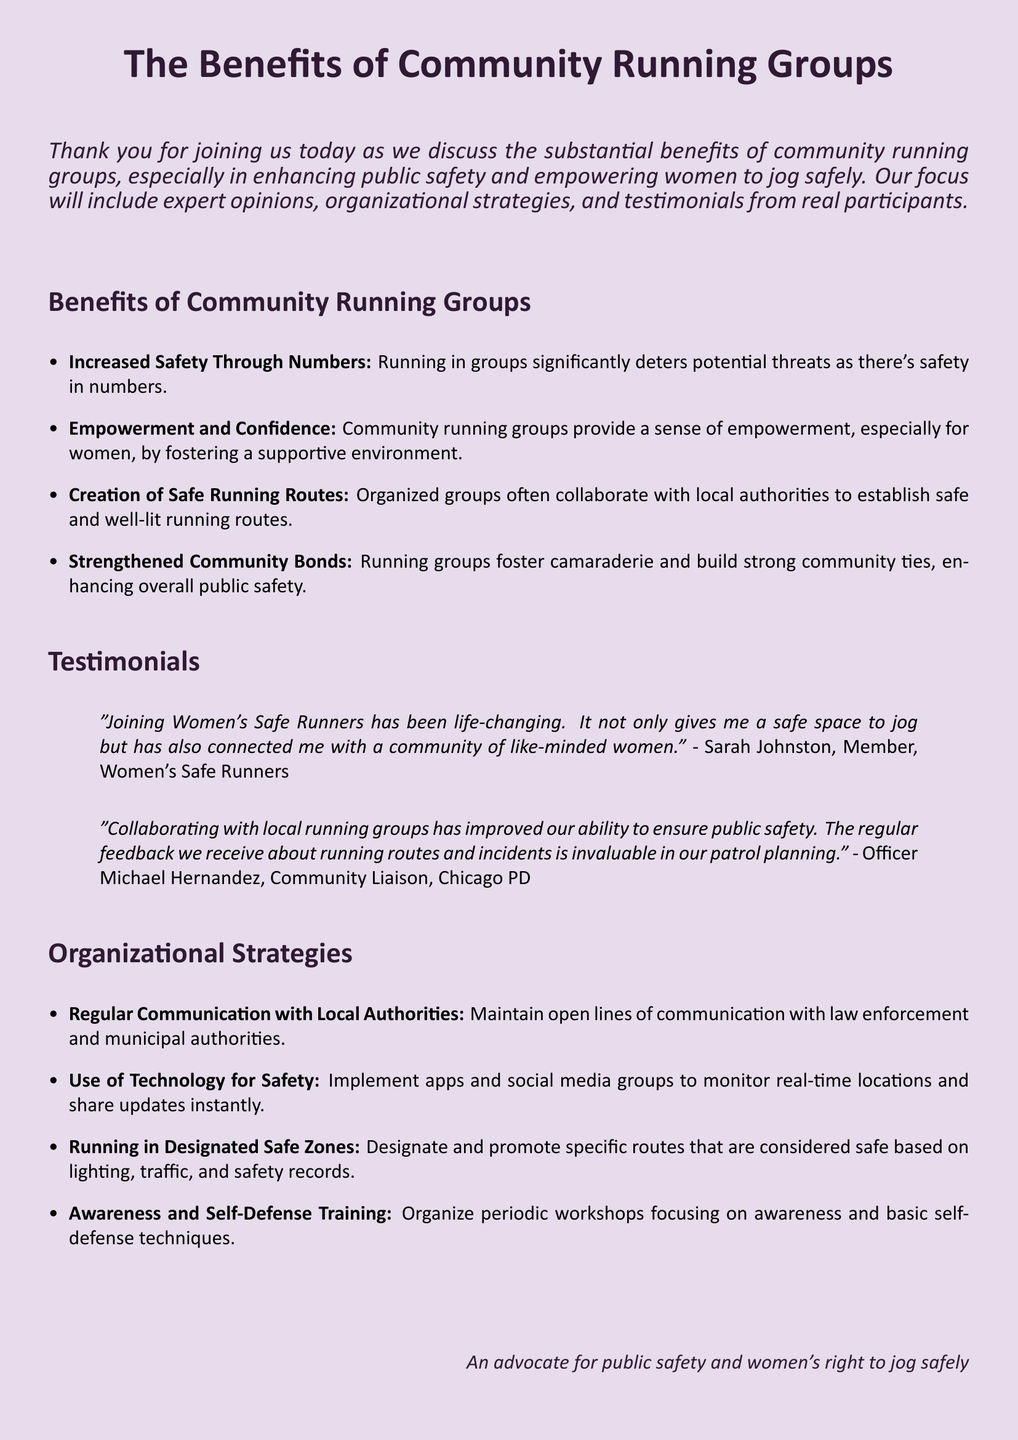What is the main focus of the document? The document discusses the benefits of community running groups in enhancing public safety and empowering women to jog safely.
Answer: Benefits of community running groups Who is quoted in the first testimonial? The first testimonial is from a member of Women's Safe Runners named Sarah Johnston.
Answer: Sarah Johnston What organizational strategy involves technology? The strategy that involves technology is about implementing apps and social media groups for monitoring.
Answer: Use of Technology for Safety What is one benefit of running in groups mentioned? One benefit mentioned is increased safety through the presence of more people.
Answer: Increased Safety Through Numbers Which local authority is collaborating with running groups? The collaborating local authority mentioned is the Chicago PD.
Answer: Chicago PD What kind of training is suggested for community runners? The document suggests organizing workshops focused on awareness and basic self-defense techniques.
Answer: Awareness and Self-Defense Training What is one way to enhance public safety through running groups? Running groups enhance public safety by creating safe and well-lit running routes.
Answer: Creation of Safe Running Routes What is highlighted as an outcome of running groups for women? The outcome highlighted is empowerment and confidence in a supportive environment.
Answer: Empowerment and Confidence 